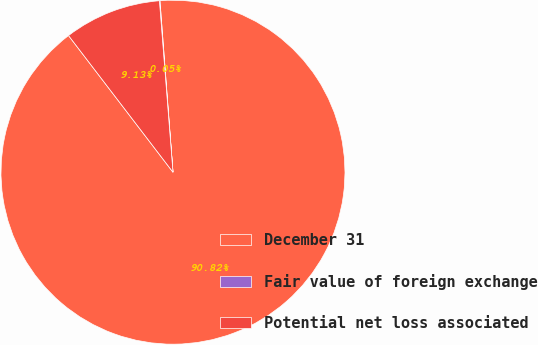Convert chart. <chart><loc_0><loc_0><loc_500><loc_500><pie_chart><fcel>December 31<fcel>Fair value of foreign exchange<fcel>Potential net loss associated<nl><fcel>90.82%<fcel>0.05%<fcel>9.13%<nl></chart> 